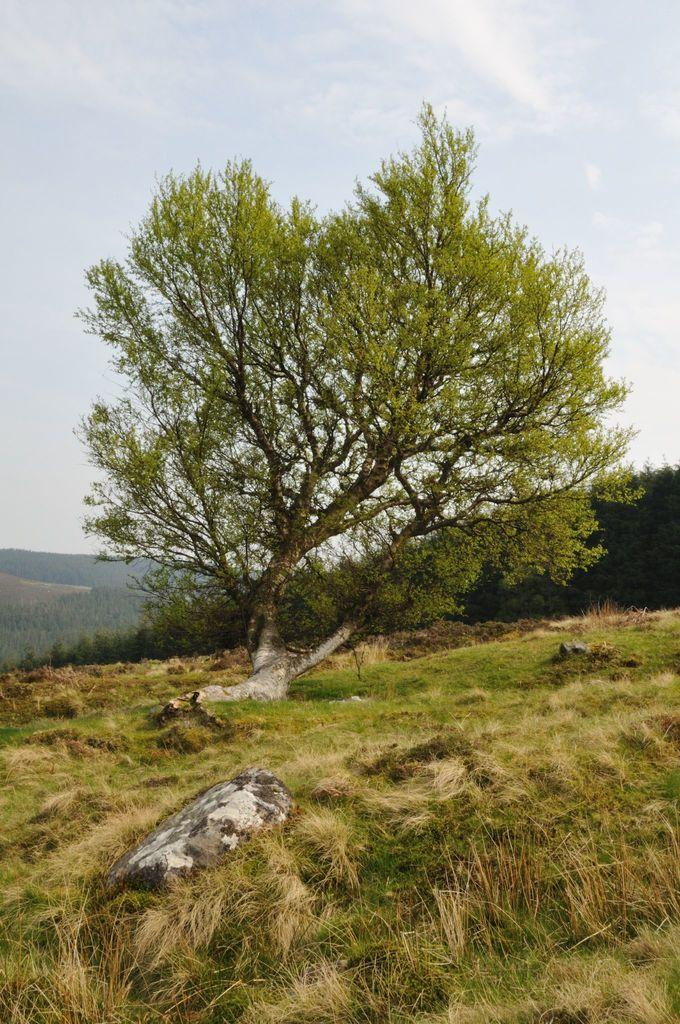What type of vegetation is present in the image? There are many trees in the image. What geographical features can be seen in the image? There are hills in the image. What part of the natural environment is visible in the image? The sky is visible in the image. What type of terrain is present in the image? There is a grassy land in the image. Can you tell me how many bubbles are floating in the sky in the image? There are no bubbles present in the image; it features trees, hills, sky, and grassy land. What type of adjustment is being made to the trees in the image? There is no adjustment being made to the trees in the image; they are simply standing in the landscape. 